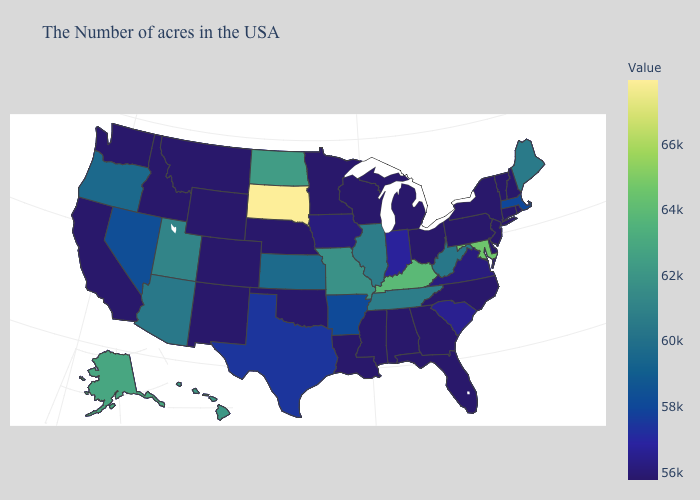Which states hav the highest value in the South?
Write a very short answer. Maryland. Which states have the lowest value in the Northeast?
Give a very brief answer. Rhode Island, New Hampshire, Vermont, Connecticut, New York, New Jersey, Pennsylvania. Among the states that border Wyoming , which have the highest value?
Short answer required. South Dakota. Which states have the highest value in the USA?
Quick response, please. South Dakota. Does South Carolina have the lowest value in the USA?
Write a very short answer. No. Among the states that border New Hampshire , which have the lowest value?
Short answer required. Vermont. Is the legend a continuous bar?
Write a very short answer. Yes. 